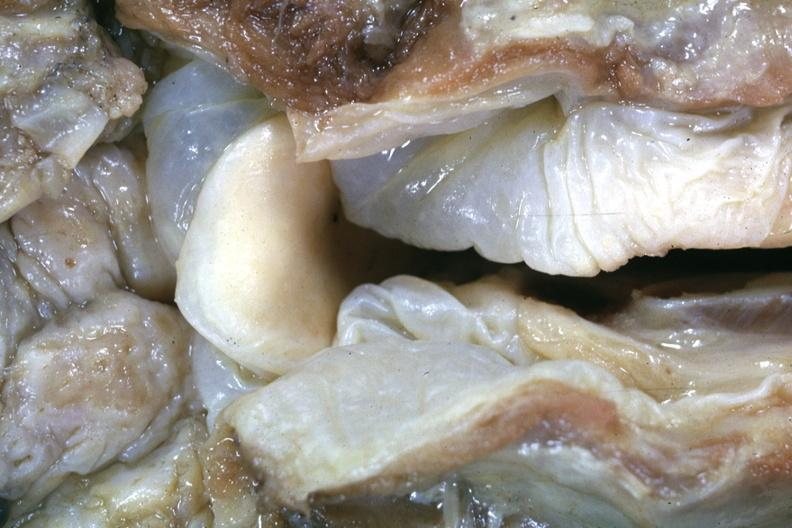what is present?
Answer the question using a single word or phrase. Oral 